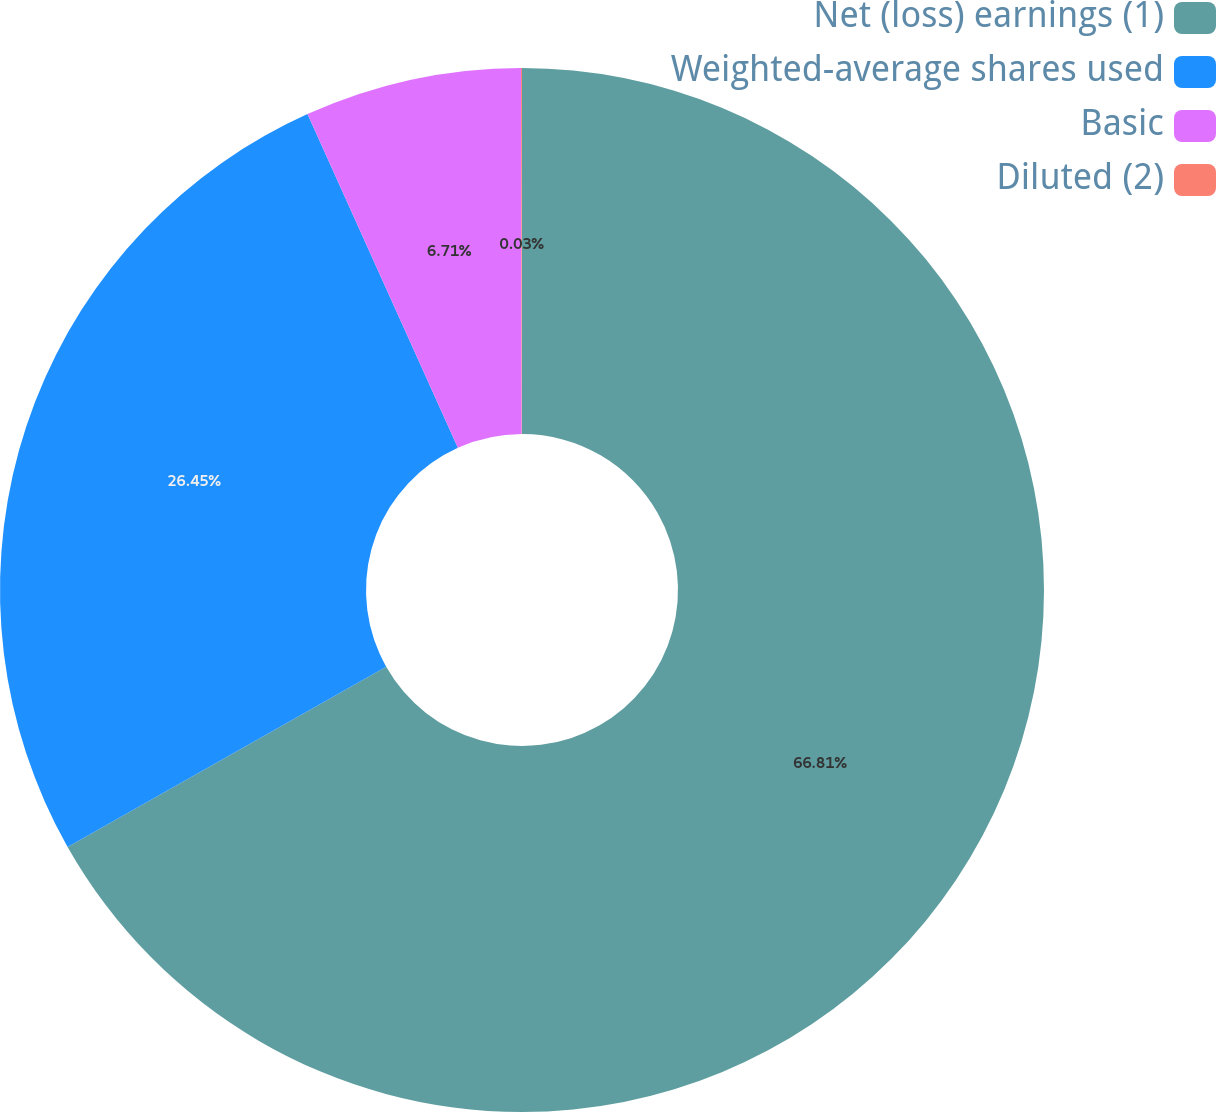Convert chart to OTSL. <chart><loc_0><loc_0><loc_500><loc_500><pie_chart><fcel>Net (loss) earnings (1)<fcel>Weighted-average shares used<fcel>Basic<fcel>Diluted (2)<nl><fcel>66.81%<fcel>26.45%<fcel>6.71%<fcel>0.03%<nl></chart> 